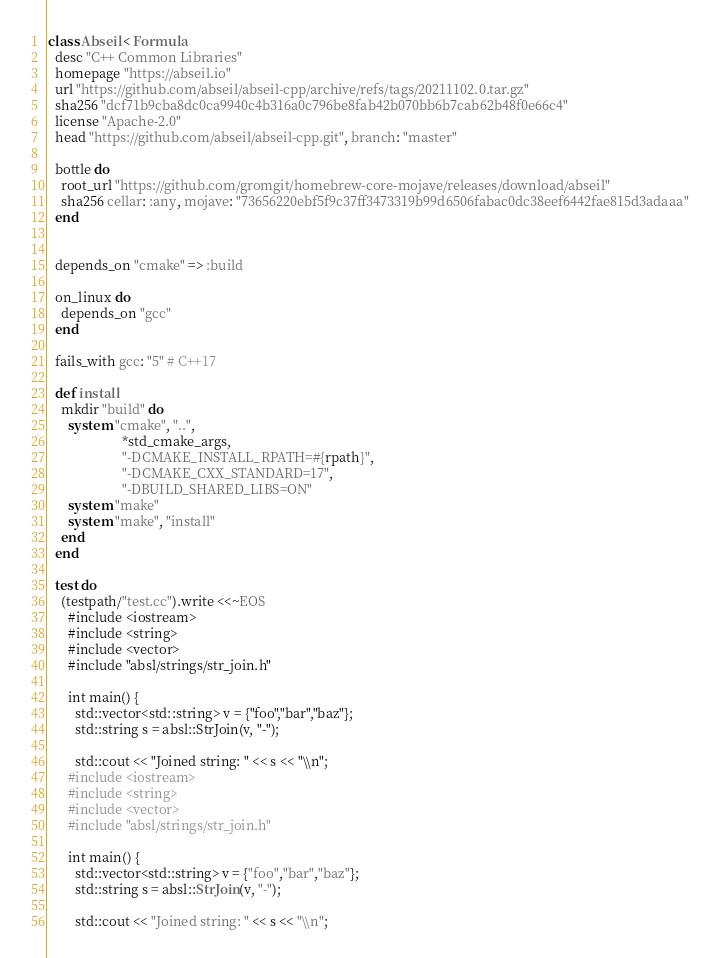<code> <loc_0><loc_0><loc_500><loc_500><_Ruby_>class Abseil < Formula
  desc "C++ Common Libraries"
  homepage "https://abseil.io"
  url "https://github.com/abseil/abseil-cpp/archive/refs/tags/20211102.0.tar.gz"
  sha256 "dcf71b9cba8dc0ca9940c4b316a0c796be8fab42b070bb6b7cab62b48f0e66c4"
  license "Apache-2.0"
  head "https://github.com/abseil/abseil-cpp.git", branch: "master"

  bottle do
    root_url "https://github.com/gromgit/homebrew-core-mojave/releases/download/abseil"
    sha256 cellar: :any, mojave: "73656220ebf5f9c37ff3473319b99d6506fabac0dc38eef6442fae815d3adaaa"
  end


  depends_on "cmake" => :build

  on_linux do
    depends_on "gcc"
  end

  fails_with gcc: "5" # C++17

  def install
    mkdir "build" do
      system "cmake", "..",
                      *std_cmake_args,
                      "-DCMAKE_INSTALL_RPATH=#{rpath}",
                      "-DCMAKE_CXX_STANDARD=17",
                      "-DBUILD_SHARED_LIBS=ON"
      system "make"
      system "make", "install"
    end
  end

  test do
    (testpath/"test.cc").write <<~EOS
      #include <iostream>
      #include <string>
      #include <vector>
      #include "absl/strings/str_join.h"

      int main() {
        std::vector<std::string> v = {"foo","bar","baz"};
        std::string s = absl::StrJoin(v, "-");

        std::cout << "Joined string: " << s << "\\n";</code> 